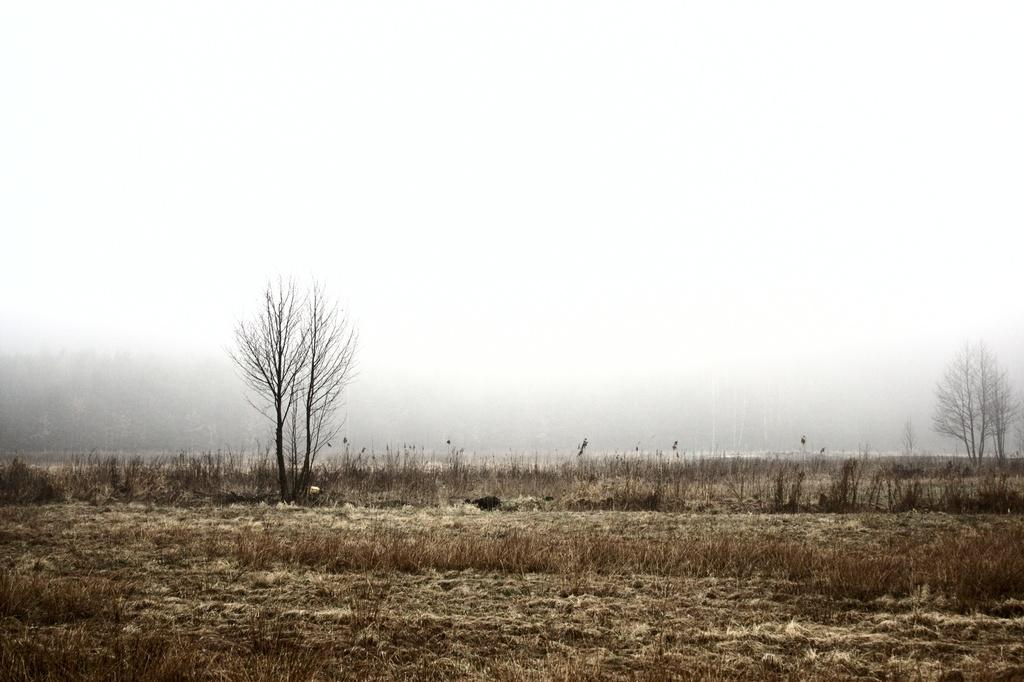What type of surface is visible in the image? There is a grass surface in the image. What can be found on the grass surface? There is a grass plant on the grass surface. What type of vegetation is present in the image, but not on the grass surface? There are dried trees in the image. What atmospheric condition can be seen in the background of the image? There is fog visible in the background of the image. Can you provide an example of a note that is present in the image? There are no notes present in the image; it features a grass surface, a grass plant, dried trees, and fog. 